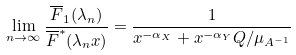Convert formula to latex. <formula><loc_0><loc_0><loc_500><loc_500>\lim _ { n \to \infty } \frac { \overline { F } _ { 1 } ( \lambda _ { n } ) } { \overline { F } ^ { * } ( \lambda _ { n } x ) } & = \frac { 1 } { x ^ { - \alpha _ { X } } + x ^ { - \alpha _ { Y } } Q / \mu _ { A ^ { - 1 } } }</formula> 